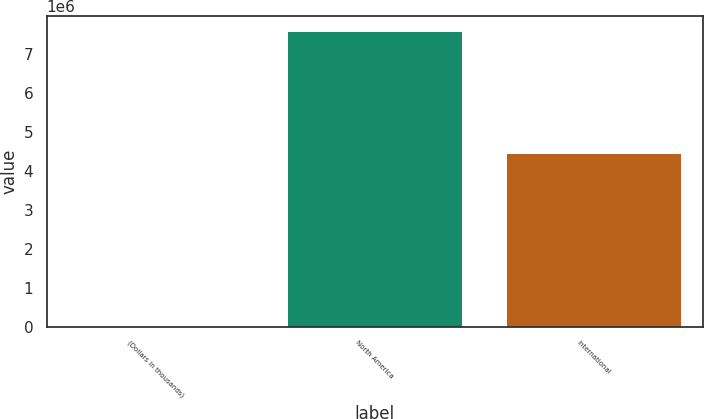Convert chart to OTSL. <chart><loc_0><loc_0><loc_500><loc_500><bar_chart><fcel>(Dollars in thousands)<fcel>North America<fcel>International<nl><fcel>2017<fcel>7.58569e+06<fcel>4.44362e+06<nl></chart> 